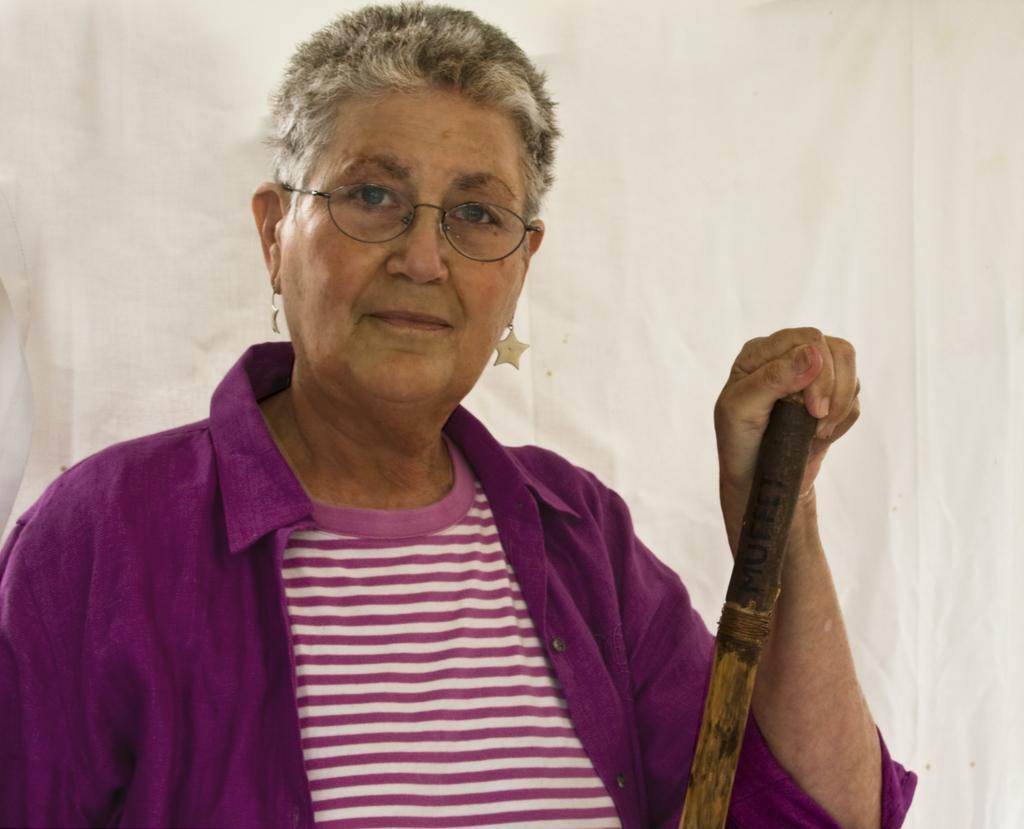In one or two sentences, can you explain what this image depicts? In this image we can see a lady standing and holding a stick. In the background there is a cloth. 